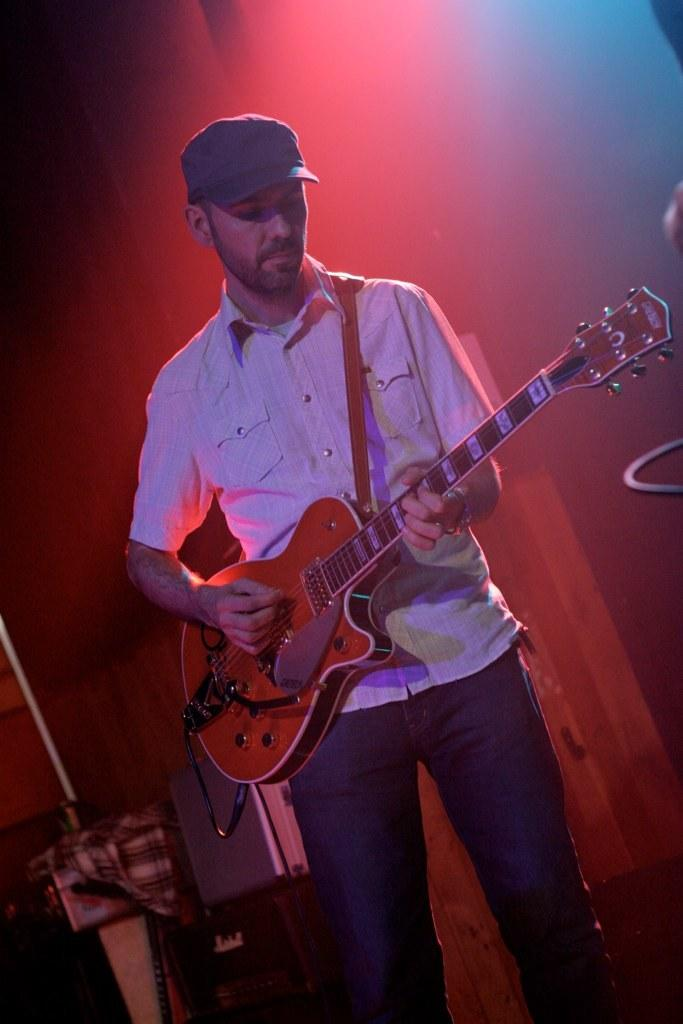What is the main subject of the image? The main subject of the image is a man. Where is the man positioned in the image? The man is standing in the center of the image. What is the man holding in his hand? The man is holding a guitar in his hand. What type of plane can be seen flying in the background of the image? There is no plane visible in the image; it only features a man standing in the center and holding a guitar. Can you tell me how many plants are present in the plantation shown in the image? There is no plantation or plants present in the image; it only features a man standing in the center and holding a guitar. 